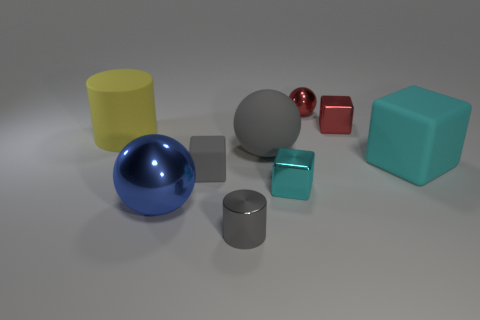Which objects in the image seem to have reflective surfaces? The objects with reflective surfaces in the image are the blue and red spheres and the gray cylinder. These surfaces catch the light in such a way that they reflect the environment around them, giving off a shiny appearance. 